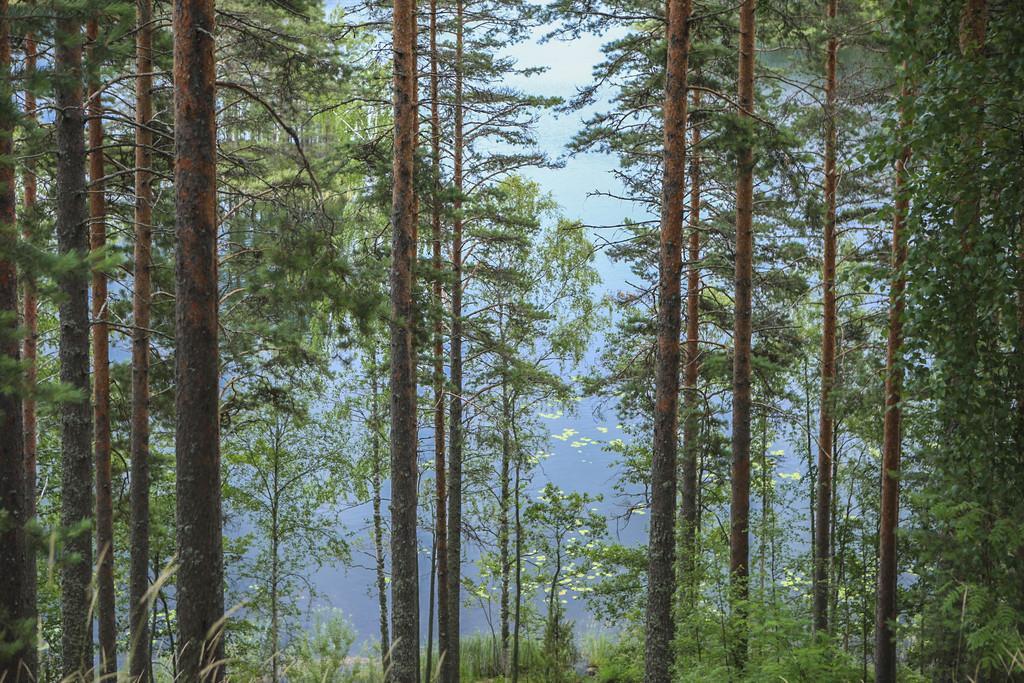How would you summarize this image in a sentence or two? In the picture we can see a long branch trees and some plants besides it. 